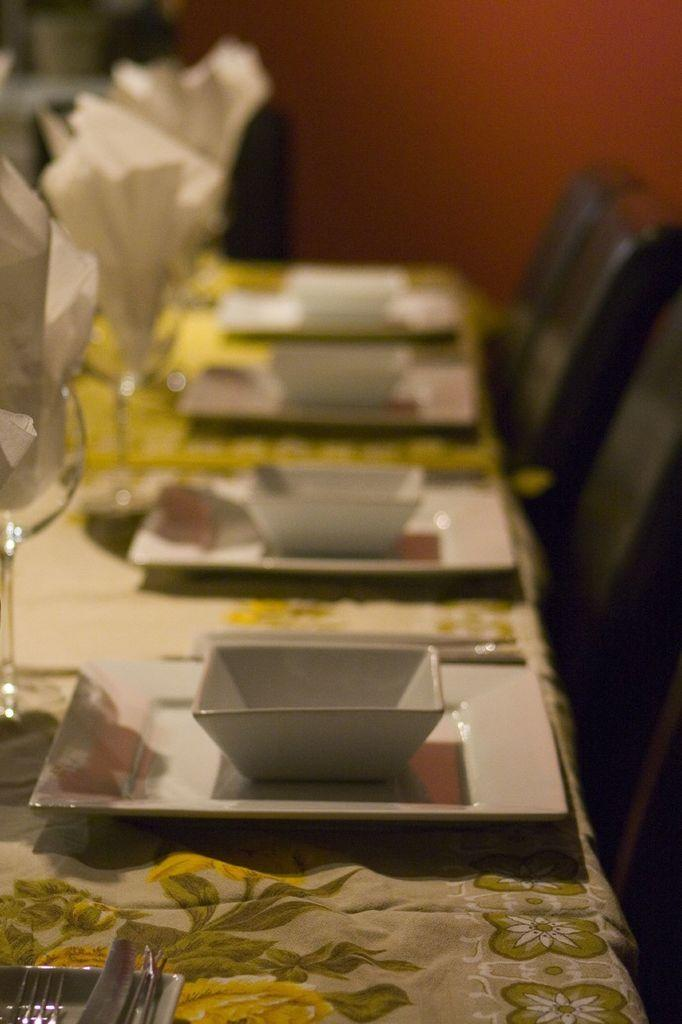What type of furniture is present in the image? There are chairs and a table in the image. What items can be seen on the table? There are plates, bowls, spoons, tissues, and glasses on the table. How many types of tableware are visible on the table? There are three types of tableware visible on the table: spoons, plates, and bowls. What degree of difficulty is the person experiencing while on vacation in the image? There is no indication of a person or a vacation in the image; it only shows chairs, a table, and various items on the table. 